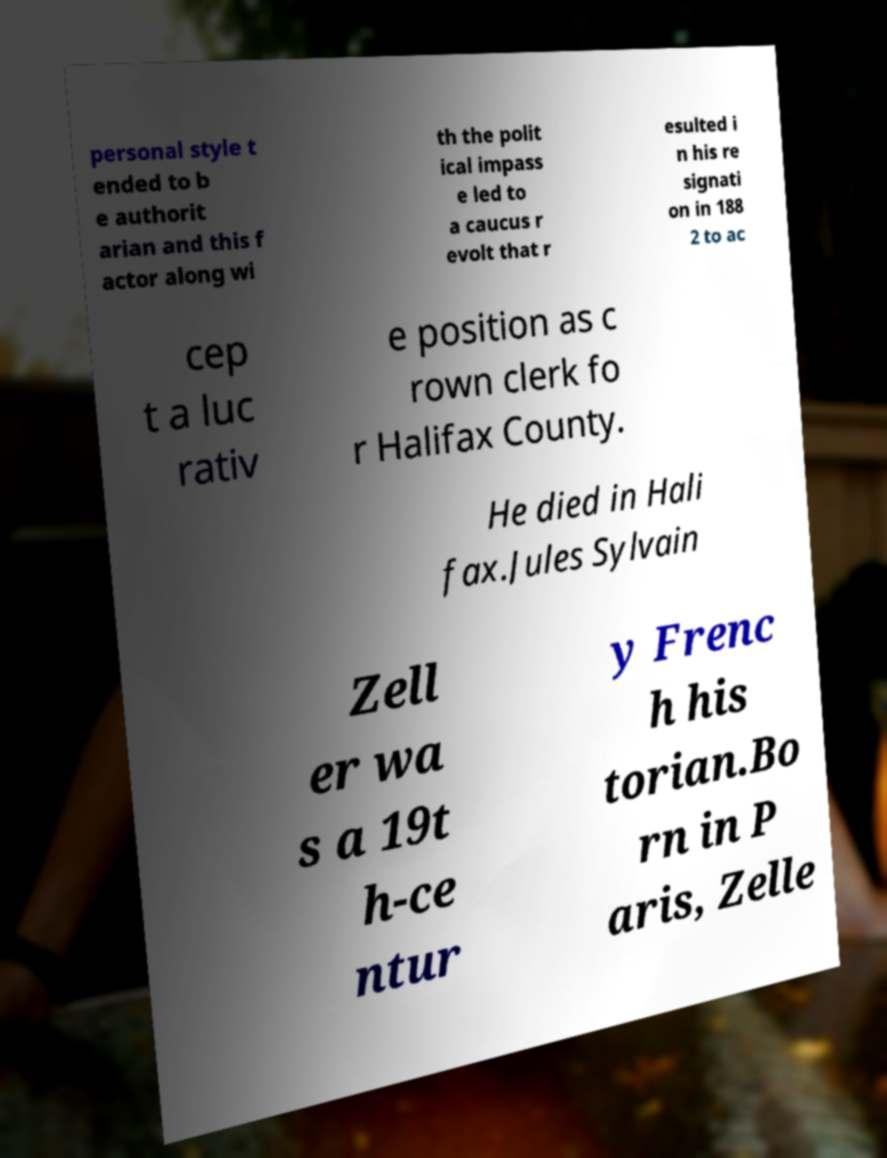Can you accurately transcribe the text from the provided image for me? personal style t ended to b e authorit arian and this f actor along wi th the polit ical impass e led to a caucus r evolt that r esulted i n his re signati on in 188 2 to ac cep t a luc rativ e position as c rown clerk fo r Halifax County. He died in Hali fax.Jules Sylvain Zell er wa s a 19t h-ce ntur y Frenc h his torian.Bo rn in P aris, Zelle 